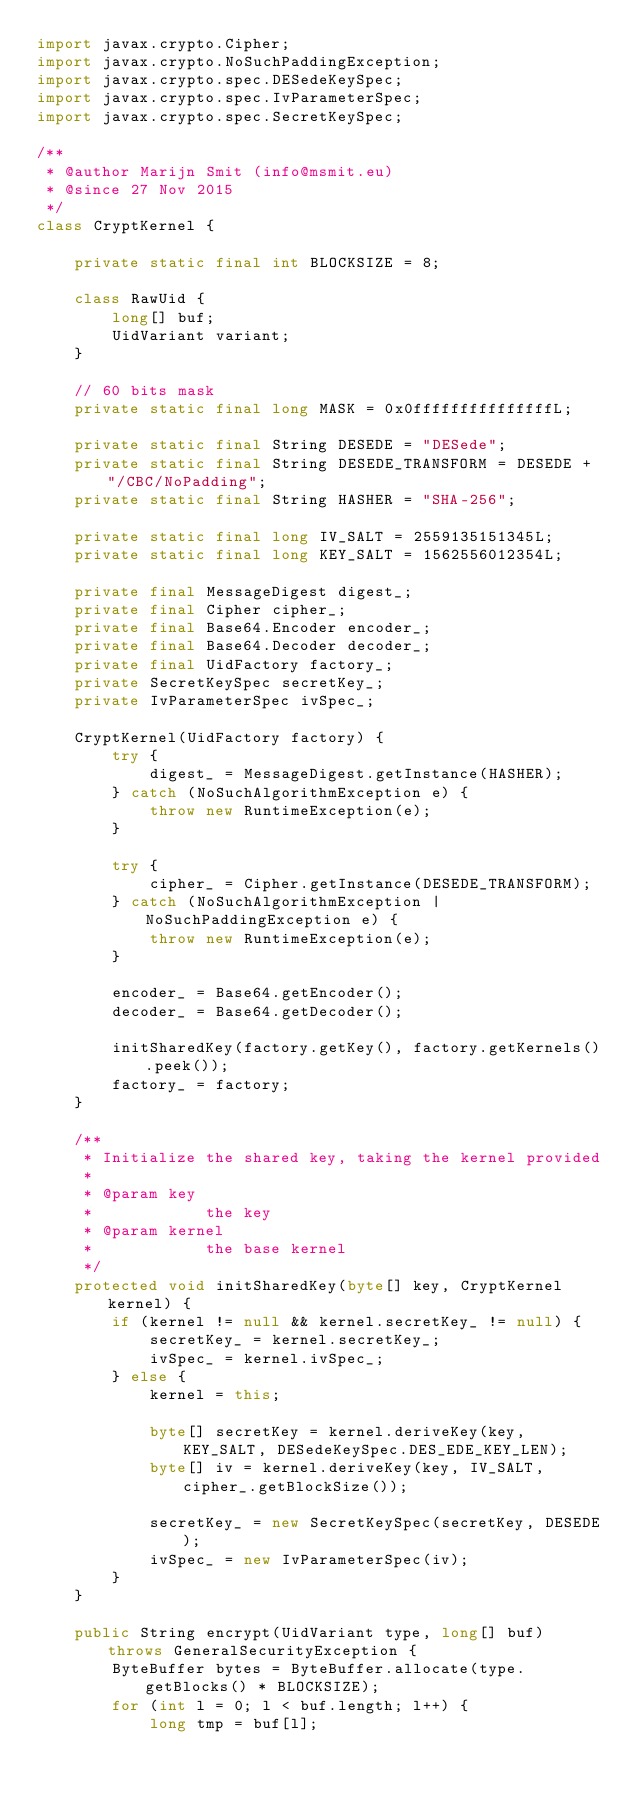<code> <loc_0><loc_0><loc_500><loc_500><_Java_>import javax.crypto.Cipher;
import javax.crypto.NoSuchPaddingException;
import javax.crypto.spec.DESedeKeySpec;
import javax.crypto.spec.IvParameterSpec;
import javax.crypto.spec.SecretKeySpec;

/**
 * @author Marijn Smit (info@msmit.eu)
 * @since 27 Nov 2015
 */
class CryptKernel {

	private static final int BLOCKSIZE = 8;

	class RawUid {
		long[] buf;
		UidVariant variant;
	}

	// 60 bits mask
	private static final long MASK = 0x0fffffffffffffffL;

	private static final String DESEDE = "DESede";
	private static final String DESEDE_TRANSFORM = DESEDE + "/CBC/NoPadding";
	private static final String HASHER = "SHA-256";

	private static final long IV_SALT = 2559135151345L;
	private static final long KEY_SALT = 1562556012354L;

	private final MessageDigest digest_;
	private final Cipher cipher_;
	private final Base64.Encoder encoder_;
	private final Base64.Decoder decoder_;
	private final UidFactory factory_;
	private SecretKeySpec secretKey_;
	private IvParameterSpec ivSpec_;

	CryptKernel(UidFactory factory) {
		try {
			digest_ = MessageDigest.getInstance(HASHER);
		} catch (NoSuchAlgorithmException e) {
			throw new RuntimeException(e);
		}

		try {
			cipher_ = Cipher.getInstance(DESEDE_TRANSFORM);
		} catch (NoSuchAlgorithmException | NoSuchPaddingException e) {
			throw new RuntimeException(e);
		}

		encoder_ = Base64.getEncoder();
		decoder_ = Base64.getDecoder();

		initSharedKey(factory.getKey(), factory.getKernels().peek());
		factory_ = factory;
	}

	/**
	 * Initialize the shared key, taking the kernel provided
	 * 
	 * @param key
	 *            the key
	 * @param kernel
	 *            the base kernel
	 */
	protected void initSharedKey(byte[] key, CryptKernel kernel) {
		if (kernel != null && kernel.secretKey_ != null) {
			secretKey_ = kernel.secretKey_;
			ivSpec_ = kernel.ivSpec_;
		} else {
			kernel = this;

			byte[] secretKey = kernel.deriveKey(key, KEY_SALT, DESedeKeySpec.DES_EDE_KEY_LEN);
			byte[] iv = kernel.deriveKey(key, IV_SALT, cipher_.getBlockSize());

			secretKey_ = new SecretKeySpec(secretKey, DESEDE);
			ivSpec_ = new IvParameterSpec(iv);
		}
	}

	public String encrypt(UidVariant type, long[] buf) throws GeneralSecurityException {
		ByteBuffer bytes = ByteBuffer.allocate(type.getBlocks() * BLOCKSIZE);
		for (int l = 0; l < buf.length; l++) {
			long tmp = buf[l];</code> 